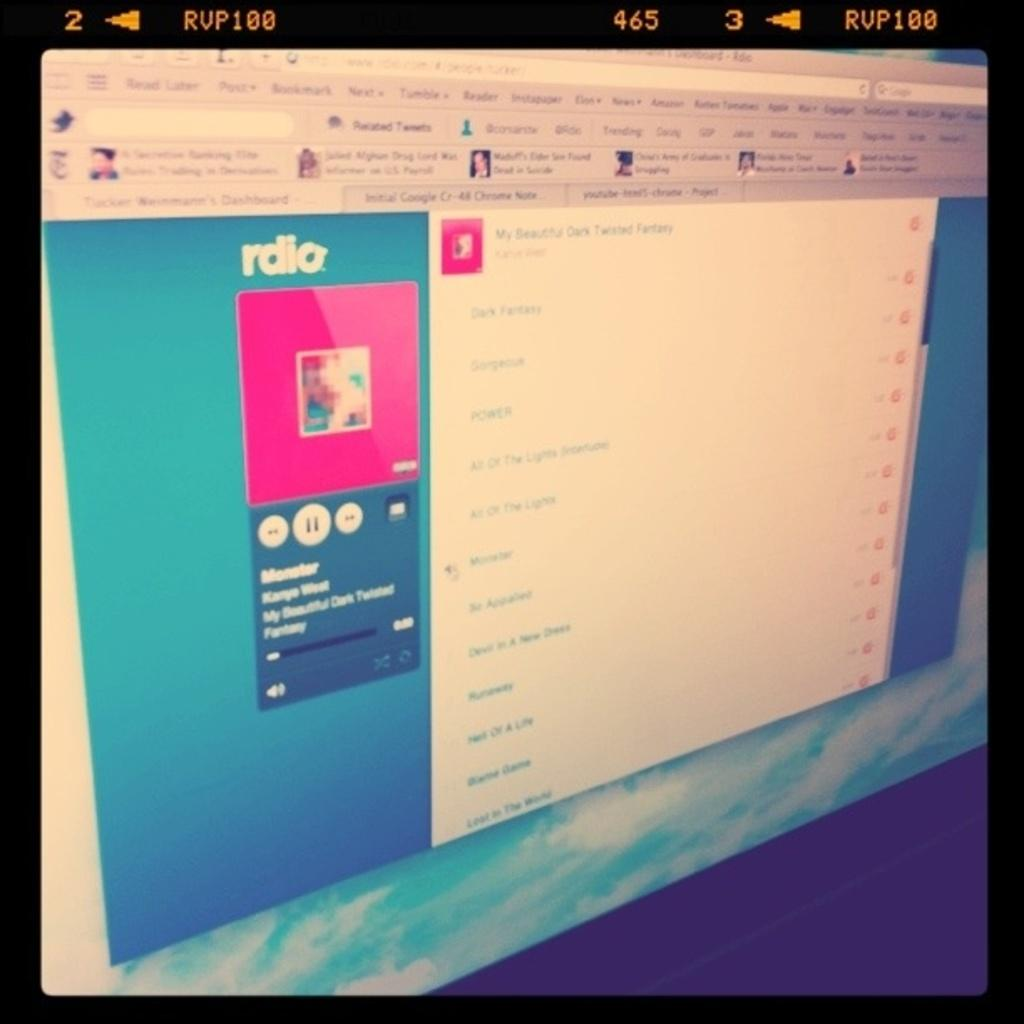<image>
Offer a succinct explanation of the picture presented. A computer screen shows a music playing service called "rdio." 